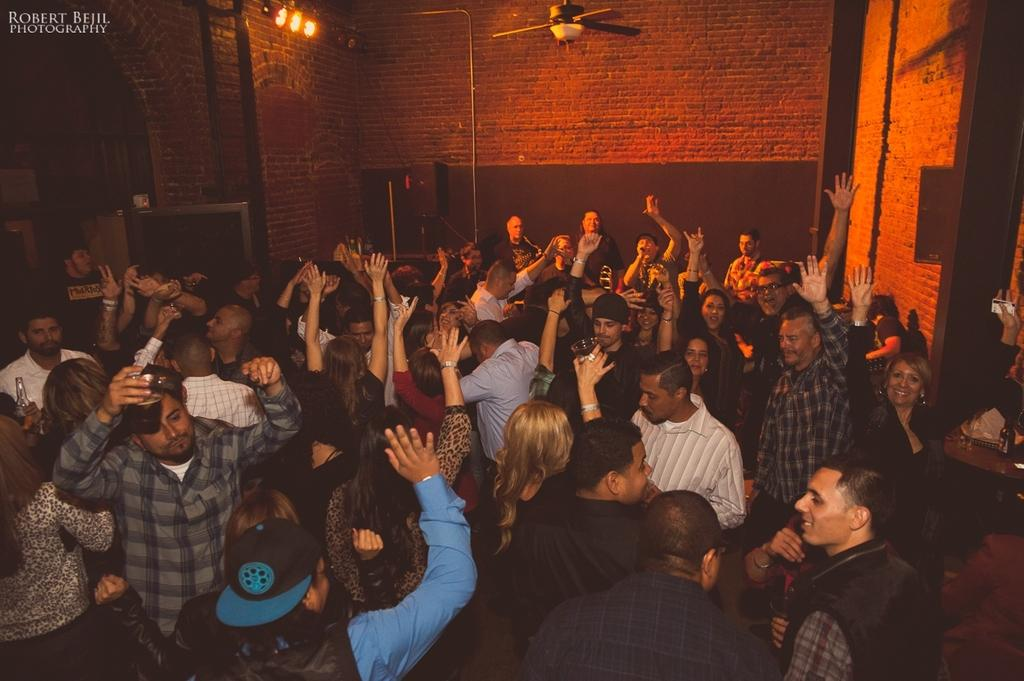What are the people in the image doing? The people in the image are dancing. What can be seen in the background or surrounding the people? There are lights and a fan visible in the image. Is there any indication of the image's origin or ownership? Yes, there is a watermark on the image. What type of thread is being used to adjust the height of the fan in the image? There is no indication of any thread being used to adjust the fan in the image, nor is there any mention of an adjustment mechanism. 